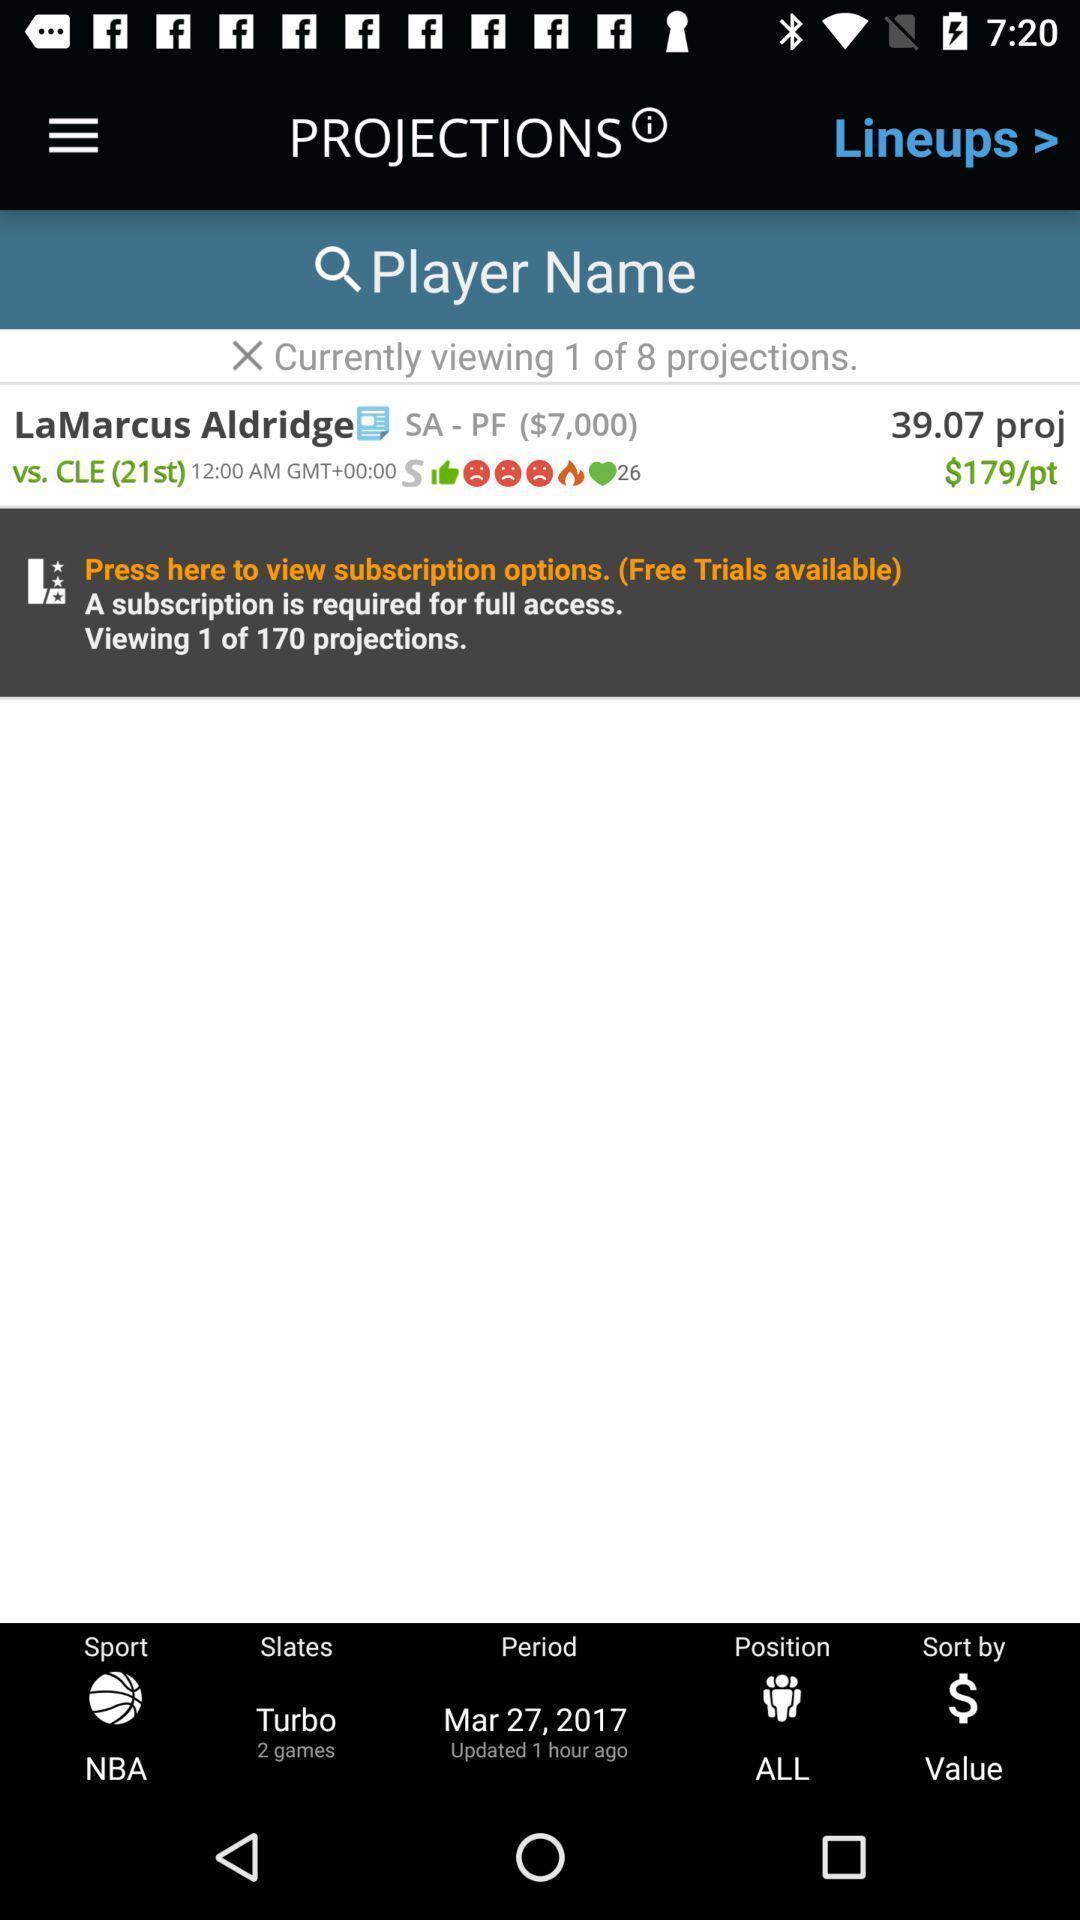Give me a narrative description of this picture. Screen shows player name details in gaming app. 